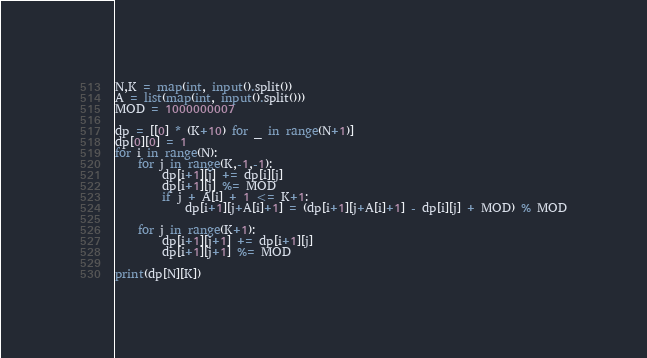<code> <loc_0><loc_0><loc_500><loc_500><_Python_>N,K = map(int, input().split())
A = list(map(int, input().split()))
MOD = 1000000007

dp = [[0] * (K+10) for _ in range(N+1)]
dp[0][0] = 1
for i in range(N):
    for j in range(K,-1,-1):
        dp[i+1][j] += dp[i][j]
        dp[i+1][j] %= MOD
        if j + A[i] + 1 <= K+1:
            dp[i+1][j+A[i]+1] = (dp[i+1][j+A[i]+1] - dp[i][j] + MOD) % MOD
    
    for j in range(K+1):
        dp[i+1][j+1] += dp[i+1][j]
        dp[i+1][j+1] %= MOD

print(dp[N][K])
</code> 